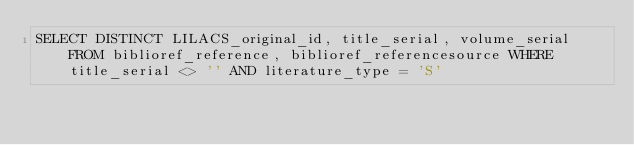Convert code to text. <code><loc_0><loc_0><loc_500><loc_500><_SQL_>SELECT DISTINCT LILACS_original_id, title_serial, volume_serial FROM biblioref_reference, biblioref_referencesource WHERE  title_serial <> '' AND literature_type = 'S'
</code> 